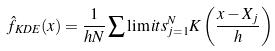<formula> <loc_0><loc_0><loc_500><loc_500>\hat { f } _ { K D E } ( x ) = \frac { 1 } { h N } \sum \lim i t s _ { j = 1 } ^ { N } K \left ( \frac { x - X _ { j } } { h } \right )</formula> 